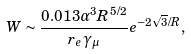Convert formula to latex. <formula><loc_0><loc_0><loc_500><loc_500>W \sim \frac { 0 . 0 1 3 \alpha ^ { 3 } R ^ { 5 / 2 } } { r _ { e } \gamma _ { \mu } } e ^ { - 2 \sqrt { 3 } / R } ,</formula> 